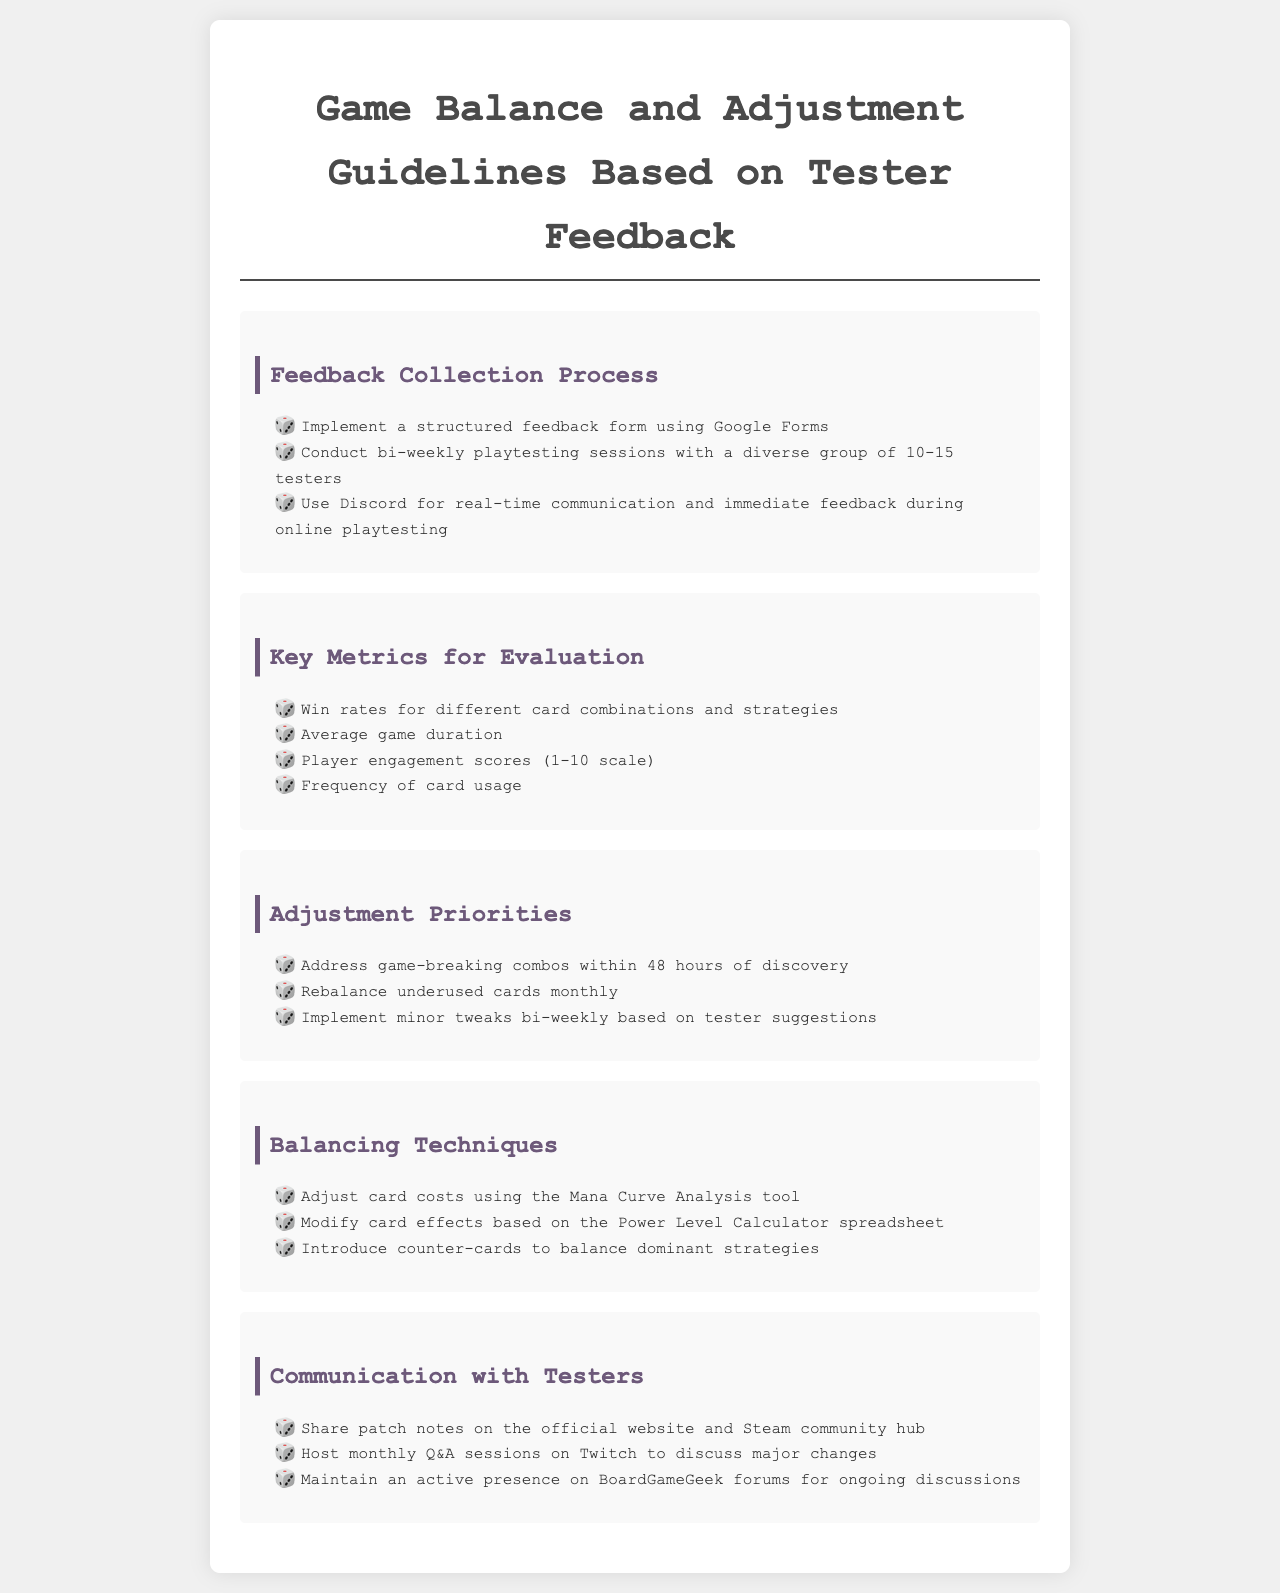What is the feedback collection process? The document outlines a structured feedback collection process that includes using Google Forms and conducting bi-weekly playtesting sessions.
Answer: Structured feedback form using Google Forms What is the win rate for evaluation? The win rate is one of the key metrics listed for evaluating game balance and adjustment.
Answer: Win rates for different card combinations and strategies How often should game-breaking combos be addressed? The document specifies a timeframe for addressing game-breaking combos as soon as they are discovered.
Answer: Within 48 hours of discovery What tool is suggested for adjusting card costs? The "Mana Curve Analysis tool" is recommended in the document for adjusting card costs.
Answer: Mana Curve Analysis tool How frequently are underused cards rebalanced? The guidelines suggest a specific frequency for rebalancing underused cards, mentioned in the document.
Answer: Monthly 